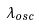<formula> <loc_0><loc_0><loc_500><loc_500>\lambda _ { o s c }</formula> 